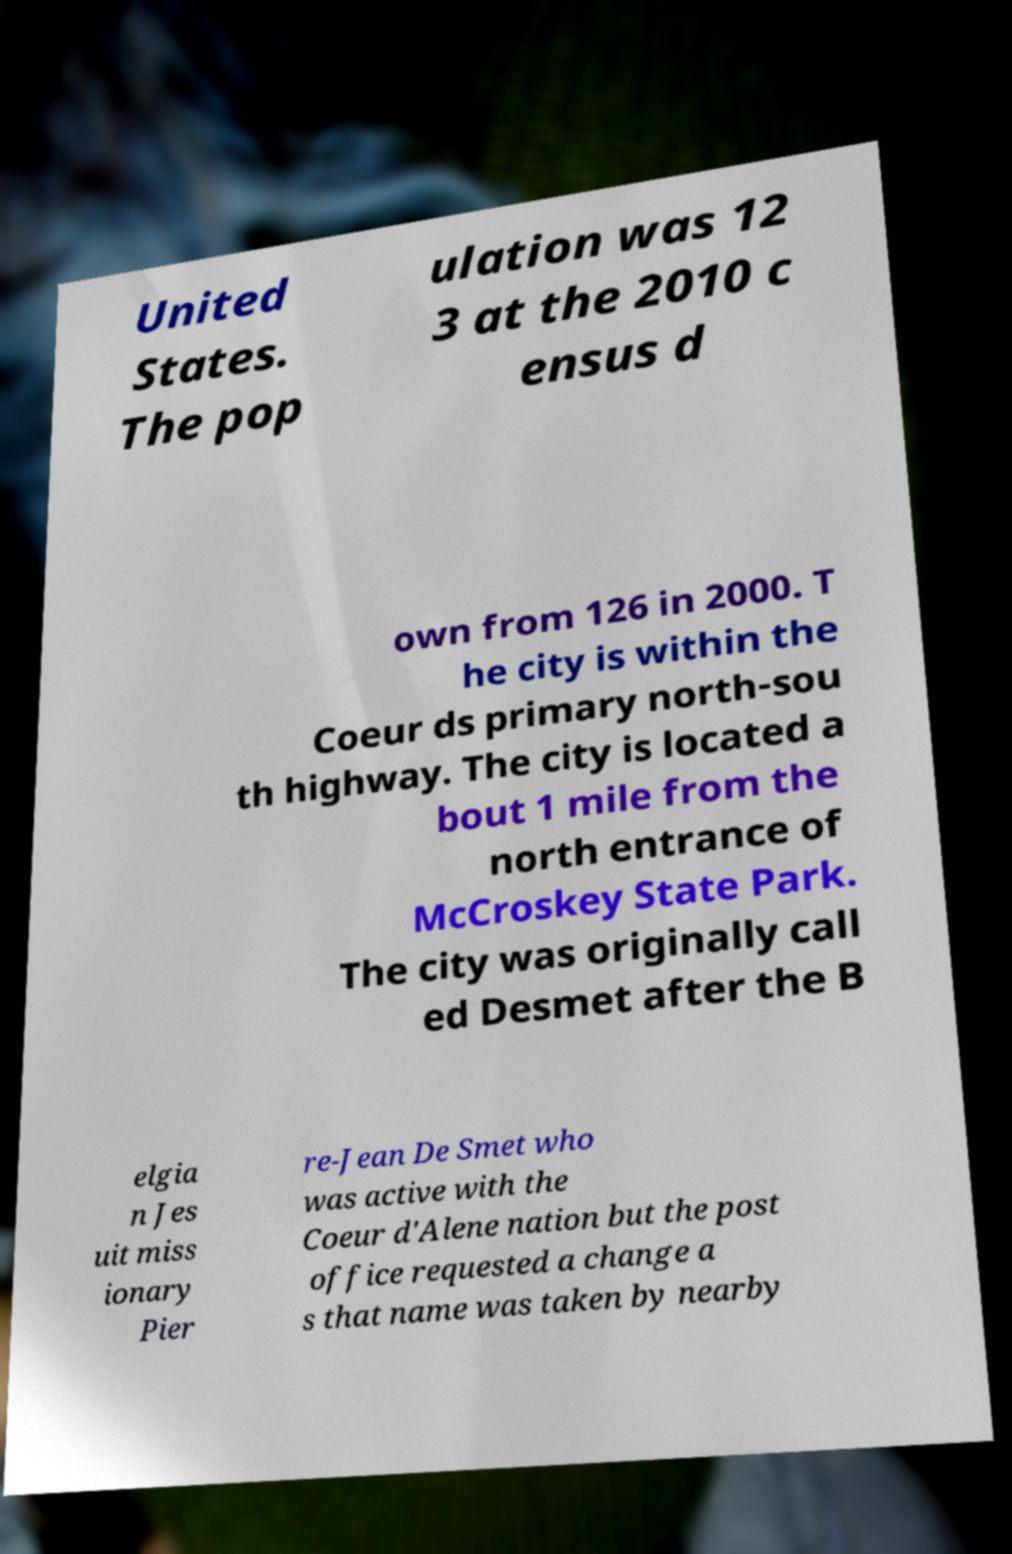Please identify and transcribe the text found in this image. United States. The pop ulation was 12 3 at the 2010 c ensus d own from 126 in 2000. T he city is within the Coeur ds primary north-sou th highway. The city is located a bout 1 mile from the north entrance of McCroskey State Park. The city was originally call ed Desmet after the B elgia n Jes uit miss ionary Pier re-Jean De Smet who was active with the Coeur d'Alene nation but the post office requested a change a s that name was taken by nearby 